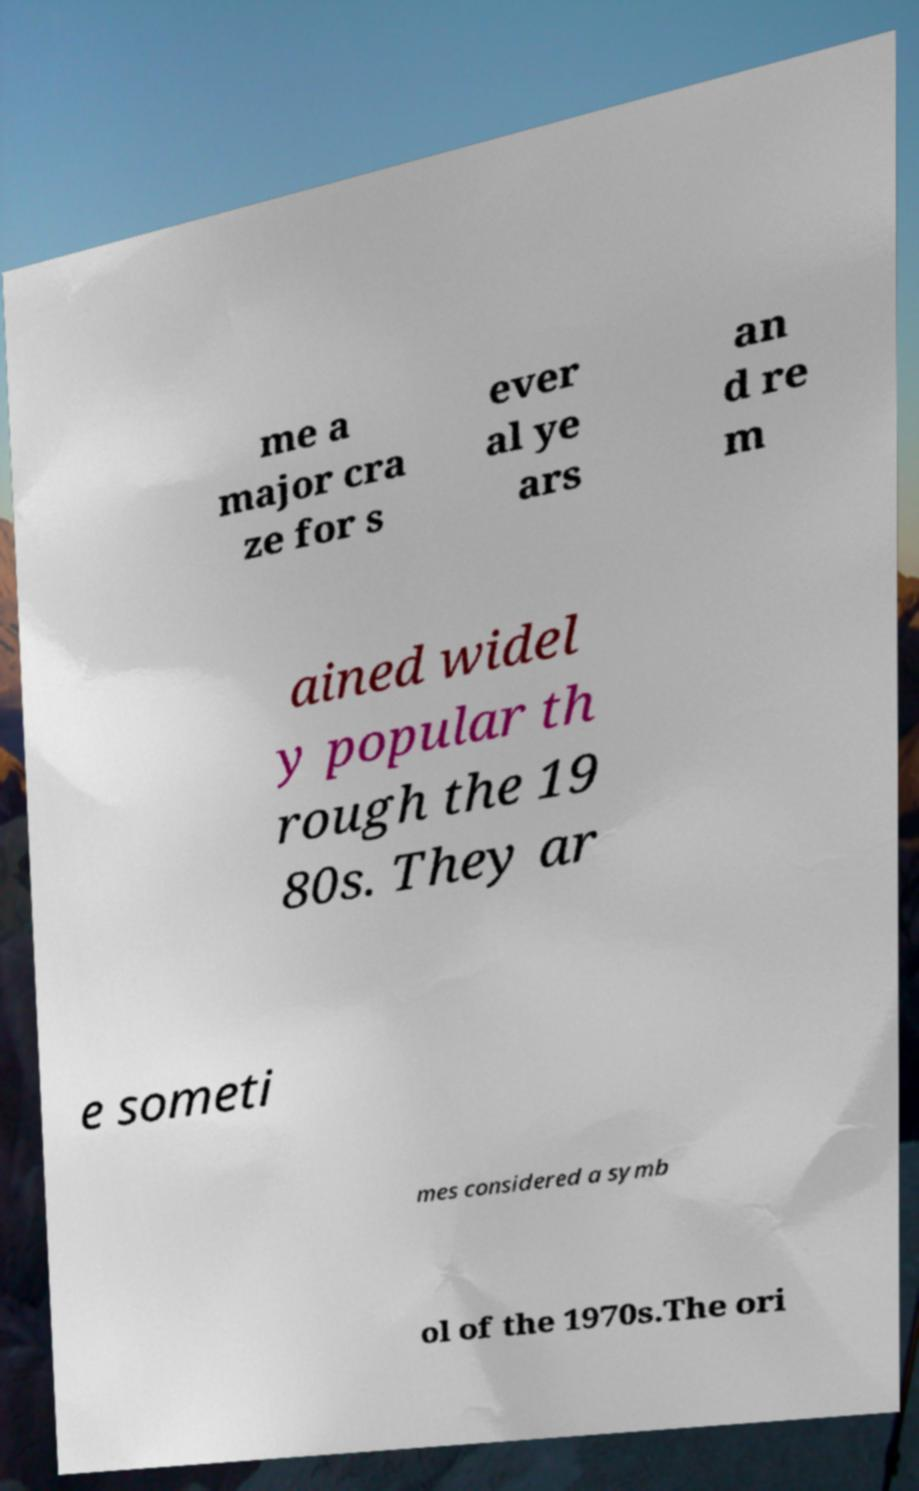Can you accurately transcribe the text from the provided image for me? me a major cra ze for s ever al ye ars an d re m ained widel y popular th rough the 19 80s. They ar e someti mes considered a symb ol of the 1970s.The ori 